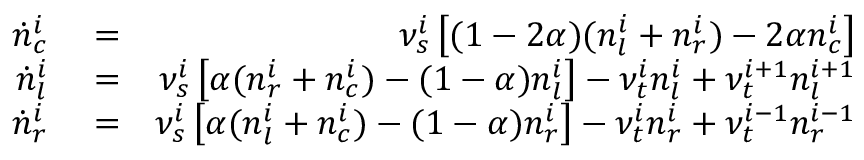<formula> <loc_0><loc_0><loc_500><loc_500>\begin{array} { r l r } { \dot { n } _ { c } ^ { i } } & = } & { \nu _ { s } ^ { i } \left [ ( 1 - 2 \alpha ) ( n _ { l } ^ { i } + n _ { r } ^ { i } ) - 2 \alpha n _ { c } ^ { i } \right ] } \\ { \dot { n } _ { l } ^ { i } } & = } & { \nu _ { s } ^ { i } \left [ \alpha ( n _ { r } ^ { i } + n _ { c } ^ { i } ) - ( 1 - \alpha ) n _ { l } ^ { i } \right ] - \nu _ { t } ^ { i } n _ { l } ^ { i } + \nu _ { t } ^ { i + 1 } n _ { l } ^ { i + 1 } } \\ { \dot { n } _ { r } ^ { i } } & = } & { \nu _ { s } ^ { i } \left [ \alpha ( n _ { l } ^ { i } + n _ { c } ^ { i } ) - ( 1 - \alpha ) n _ { r } ^ { i } \right ] - \nu _ { t } ^ { i } n _ { r } ^ { i } + \nu _ { t } ^ { i - 1 } n _ { r } ^ { i - 1 } } \end{array}</formula> 